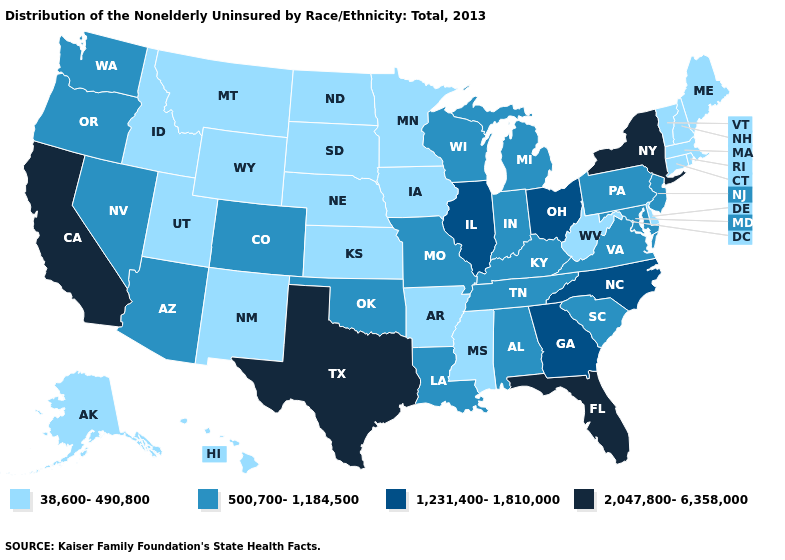Does Florida have the highest value in the USA?
Quick response, please. Yes. What is the value of Rhode Island?
Short answer required. 38,600-490,800. Does South Dakota have the same value as Connecticut?
Be succinct. Yes. Is the legend a continuous bar?
Give a very brief answer. No. Which states have the lowest value in the Northeast?
Be succinct. Connecticut, Maine, Massachusetts, New Hampshire, Rhode Island, Vermont. Name the states that have a value in the range 38,600-490,800?
Write a very short answer. Alaska, Arkansas, Connecticut, Delaware, Hawaii, Idaho, Iowa, Kansas, Maine, Massachusetts, Minnesota, Mississippi, Montana, Nebraska, New Hampshire, New Mexico, North Dakota, Rhode Island, South Dakota, Utah, Vermont, West Virginia, Wyoming. What is the value of Arkansas?
Concise answer only. 38,600-490,800. Name the states that have a value in the range 500,700-1,184,500?
Quick response, please. Alabama, Arizona, Colorado, Indiana, Kentucky, Louisiana, Maryland, Michigan, Missouri, Nevada, New Jersey, Oklahoma, Oregon, Pennsylvania, South Carolina, Tennessee, Virginia, Washington, Wisconsin. What is the highest value in states that border Indiana?
Be succinct. 1,231,400-1,810,000. Among the states that border Wisconsin , does Michigan have the highest value?
Be succinct. No. What is the lowest value in the USA?
Quick response, please. 38,600-490,800. Does New York have the lowest value in the Northeast?
Answer briefly. No. Which states hav the highest value in the West?
Be succinct. California. Name the states that have a value in the range 500,700-1,184,500?
Answer briefly. Alabama, Arizona, Colorado, Indiana, Kentucky, Louisiana, Maryland, Michigan, Missouri, Nevada, New Jersey, Oklahoma, Oregon, Pennsylvania, South Carolina, Tennessee, Virginia, Washington, Wisconsin. Name the states that have a value in the range 2,047,800-6,358,000?
Short answer required. California, Florida, New York, Texas. 